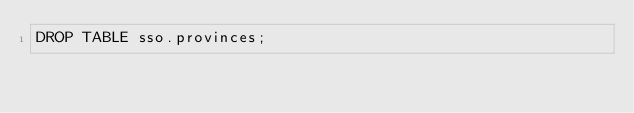<code> <loc_0><loc_0><loc_500><loc_500><_SQL_>DROP TABLE sso.provinces;</code> 